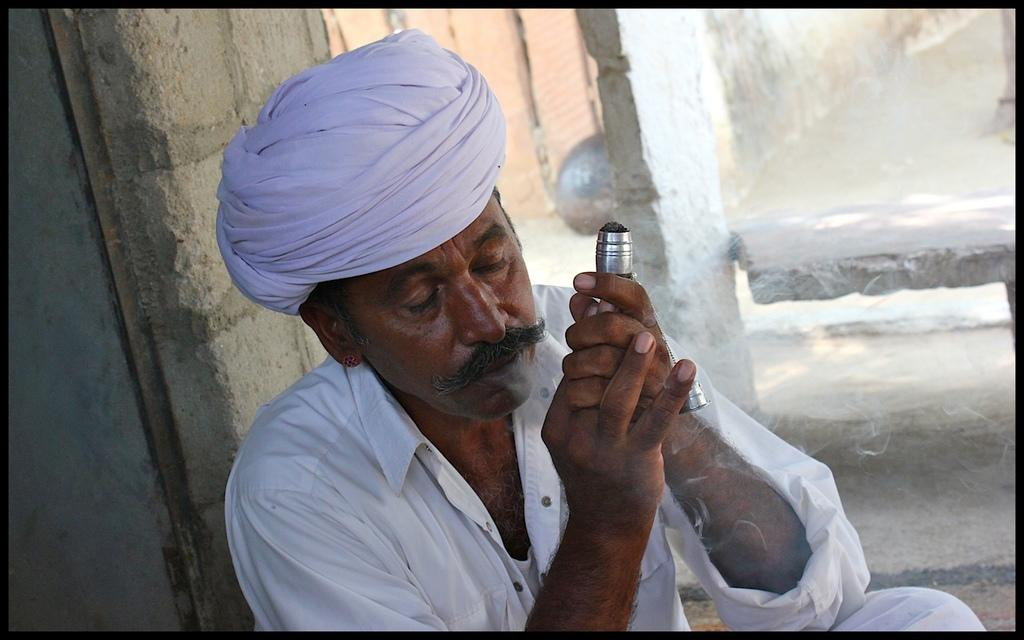Who is the main subject in the image? There is a man in the center of the image. What type of dust can be seen settling on the man's shoulder in the image? There is no dust visible on the man's shoulder in the image. What substance is the man an expert in, as seen in the image? The provided facts do not give any information about the man's expertise or any other details about the image. 